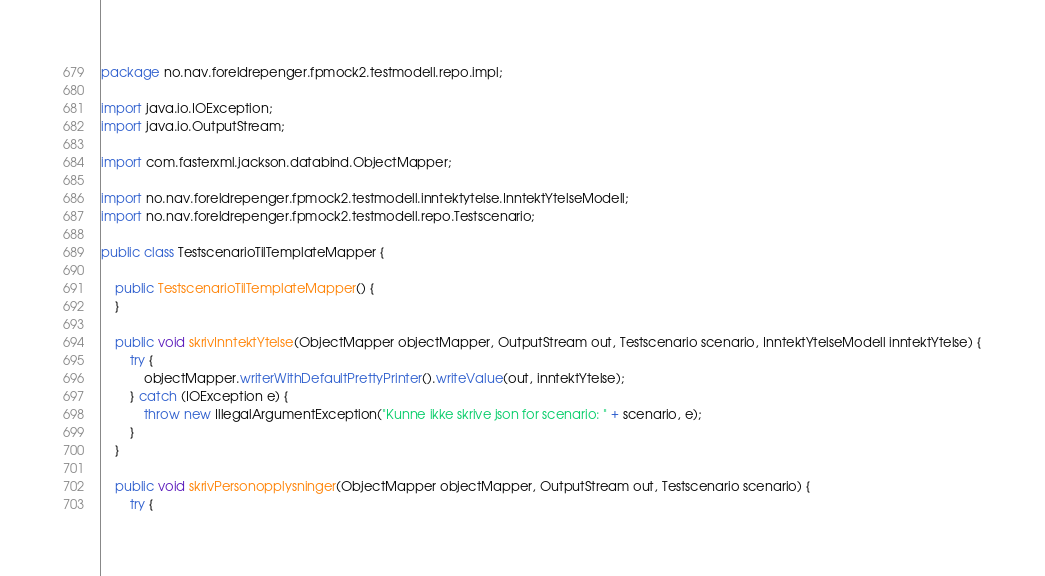Convert code to text. <code><loc_0><loc_0><loc_500><loc_500><_Java_>package no.nav.foreldrepenger.fpmock2.testmodell.repo.impl;

import java.io.IOException;
import java.io.OutputStream;

import com.fasterxml.jackson.databind.ObjectMapper;

import no.nav.foreldrepenger.fpmock2.testmodell.inntektytelse.InntektYtelseModell;
import no.nav.foreldrepenger.fpmock2.testmodell.repo.Testscenario;

public class TestscenarioTilTemplateMapper {

    public TestscenarioTilTemplateMapper() {
    }

    public void skrivInntektYtelse(ObjectMapper objectMapper, OutputStream out, Testscenario scenario, InntektYtelseModell inntektYtelse) {
        try {
            objectMapper.writerWithDefaultPrettyPrinter().writeValue(out, inntektYtelse);
        } catch (IOException e) {
            throw new IllegalArgumentException("Kunne ikke skrive json for scenario: " + scenario, e);
        }
    }

    public void skrivPersonopplysninger(ObjectMapper objectMapper, OutputStream out, Testscenario scenario) {
        try {</code> 